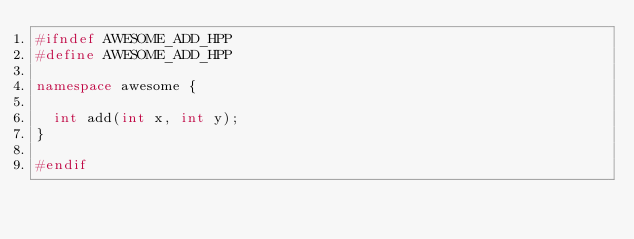<code> <loc_0><loc_0><loc_500><loc_500><_C++_>#ifndef AWESOME_ADD_HPP
#define AWESOME_ADD_HPP

namespace awesome {
  
  int add(int x, int y);
}

#endif
</code> 